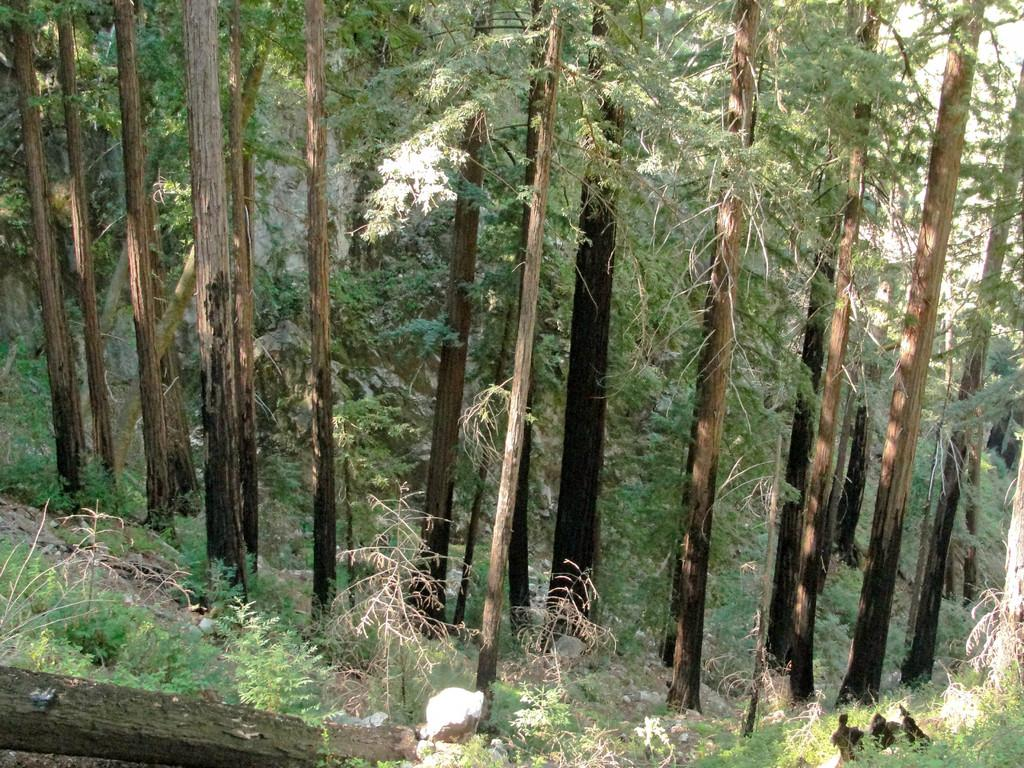What type of vegetation can be seen in the image? There are trees, plants, and grass visible in the image. Can you describe the ground in the image? The ground in the image is covered with grass. What type of furniture can be seen in the image? There is no furniture present in the image; it features natural elements like trees, plants, and grass. How does the wind affect the trees in the image? The image does not show any movement or effects of the wind on the trees. 